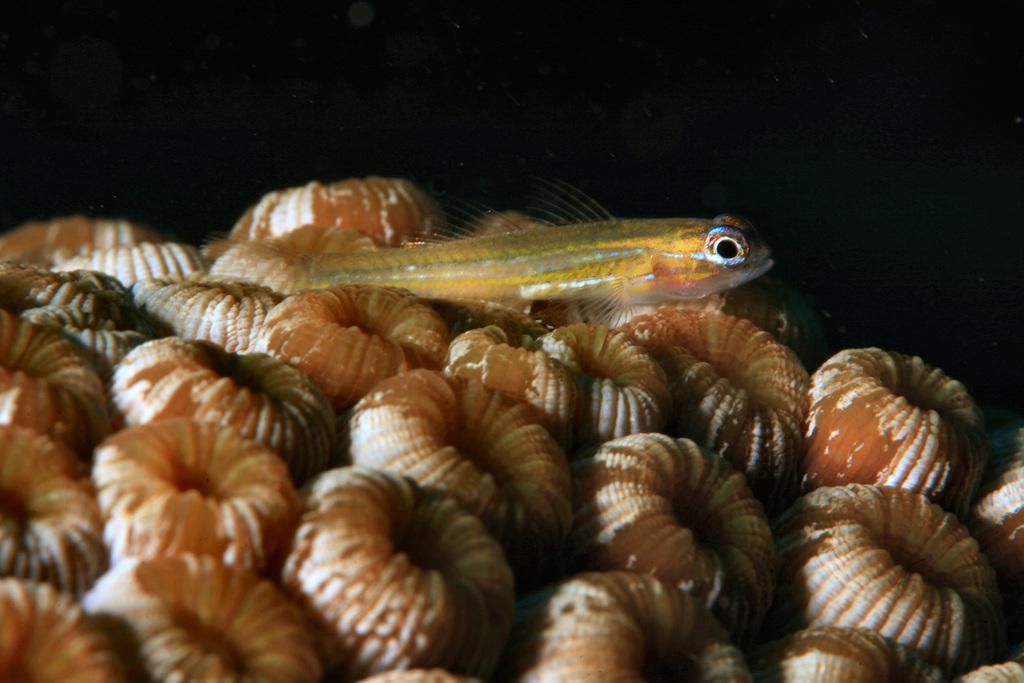Describe this image in one or two sentences. There are many round shaped shells like things. On that there is a fish. 